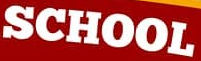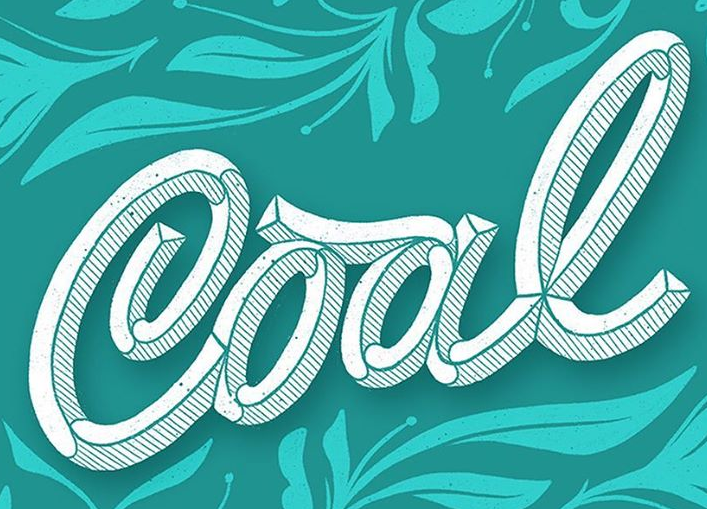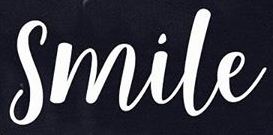Identify the words shown in these images in order, separated by a semicolon. SCHOOL; Cool; Smile 